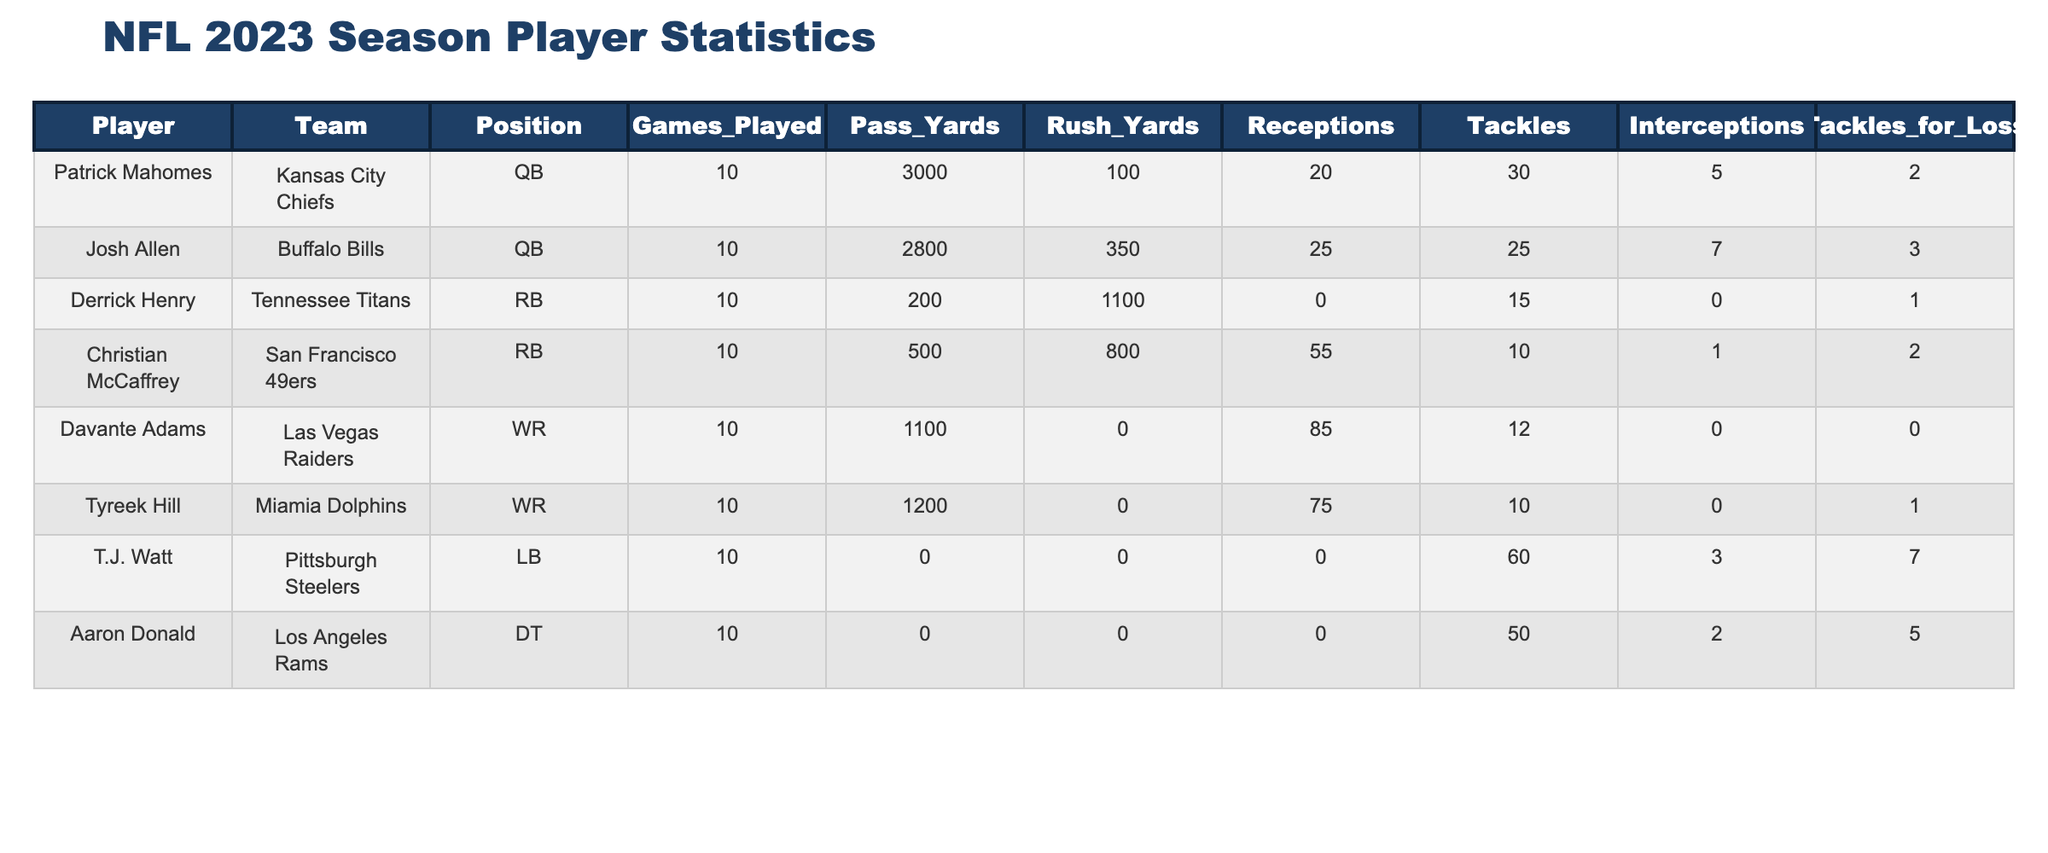What team does Patrick Mahomes play for? The table shows the player statistics, and by looking at the "Player" column, we can find Patrick Mahomes. In the same row under the "Team" column, it states that he plays for the Kansas City Chiefs.
Answer: Kansas City Chiefs How many rushing yards did Christian McCaffrey achieve this season? In the table, we can find Christian McCaffrey in the "Player" column, and by checking the same row under the "Rush_Yards" column, it shows he achieved 800 rushing yards this season.
Answer: 800 Which player has the highest number of tackles? To find this, we can scan the "Tackles" column and compare the values. T.J. Watt has 60 tackles, which is the highest compared to the other players listed.
Answer: T.J. Watt What is the total number of receptions by all players? We sum up the values in the "Receptions" column: 20 + 25 + 0 + 55 + 85 + 75 + 0 + 0 = 260. Thus, the total number of receptions by all players is 260.
Answer: 260 Did Aaron Donald have any interceptions this season? Checking the "Interceptions" column, we see that the value for Aaron Donald is 2. Therefore, the statement that he had interceptions is true.
Answer: Yes Who contributed more to passing yards, Patrick Mahomes or Josh Allen? Looking at the "Pass_Yards" column, Patrick Mahomes has 3000 passing yards and Josh Allen has 2800. Since 3000 is greater than 2800, it indicates that Patrick Mahomes contributed more to passing yards.
Answer: Patrick Mahomes What is the average number of tackles across all players? To calculate the average, first, we sum the tackles: 30 + 25 + 15 + 10 + 12 + 10 + 60 + 50 = 212. There are 8 players, so we divide the total by 8: 212 / 8 = 26.5. The average number of tackles is 26.5.
Answer: 26.5 Which player has the highest rushing yards? By scanning the "Rush_Yards" column, we see Derrick Henry has the highest value with 1100 rushing yards, compared to Christian McCaffrey's 800 yards and others with lower values.
Answer: Derrick Henry Is Tyreek Hill more of a receiver or a rusher based on his statistics? By looking at the table, Tyreek Hill has 1200 passing yards and 0 rushing yards. Since he has a significant number of receptions and no rushing yards, it indicates that he is primarily a receiver.
Answer: Receiver 